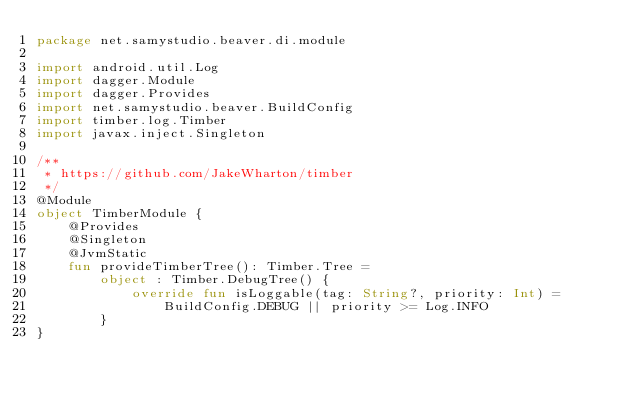Convert code to text. <code><loc_0><loc_0><loc_500><loc_500><_Kotlin_>package net.samystudio.beaver.di.module

import android.util.Log
import dagger.Module
import dagger.Provides
import net.samystudio.beaver.BuildConfig
import timber.log.Timber
import javax.inject.Singleton

/**
 * https://github.com/JakeWharton/timber
 */
@Module
object TimberModule {
    @Provides
    @Singleton
    @JvmStatic
    fun provideTimberTree(): Timber.Tree =
        object : Timber.DebugTree() {
            override fun isLoggable(tag: String?, priority: Int) =
                BuildConfig.DEBUG || priority >= Log.INFO
        }
}</code> 